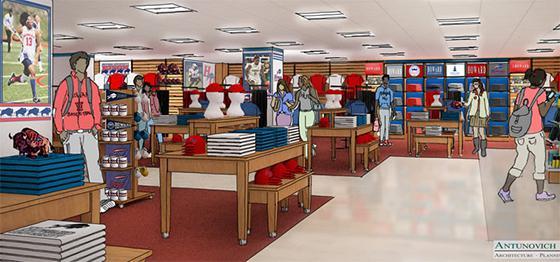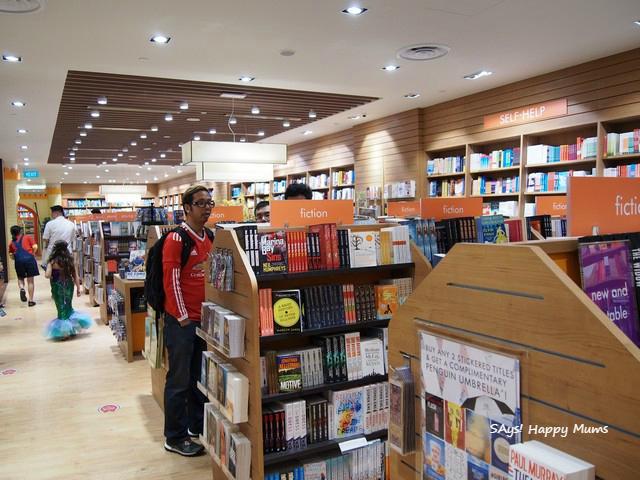The first image is the image on the left, the second image is the image on the right. Considering the images on both sides, is "An image shows a shop interior which includes displays of apparel." valid? Answer yes or no. Yes. 